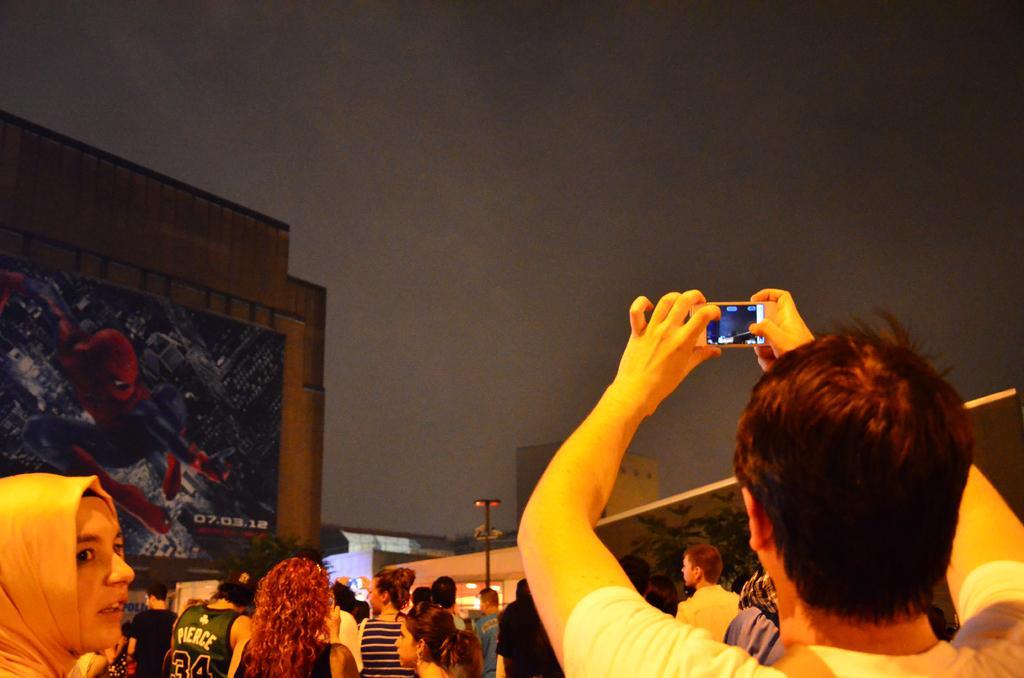In one or two sentences, can you explain what this image depicts? In this picture there are many persons watching to the sky. A person is holding a mobile phone and taking a video and to the left side there is a poster spider man poster. 